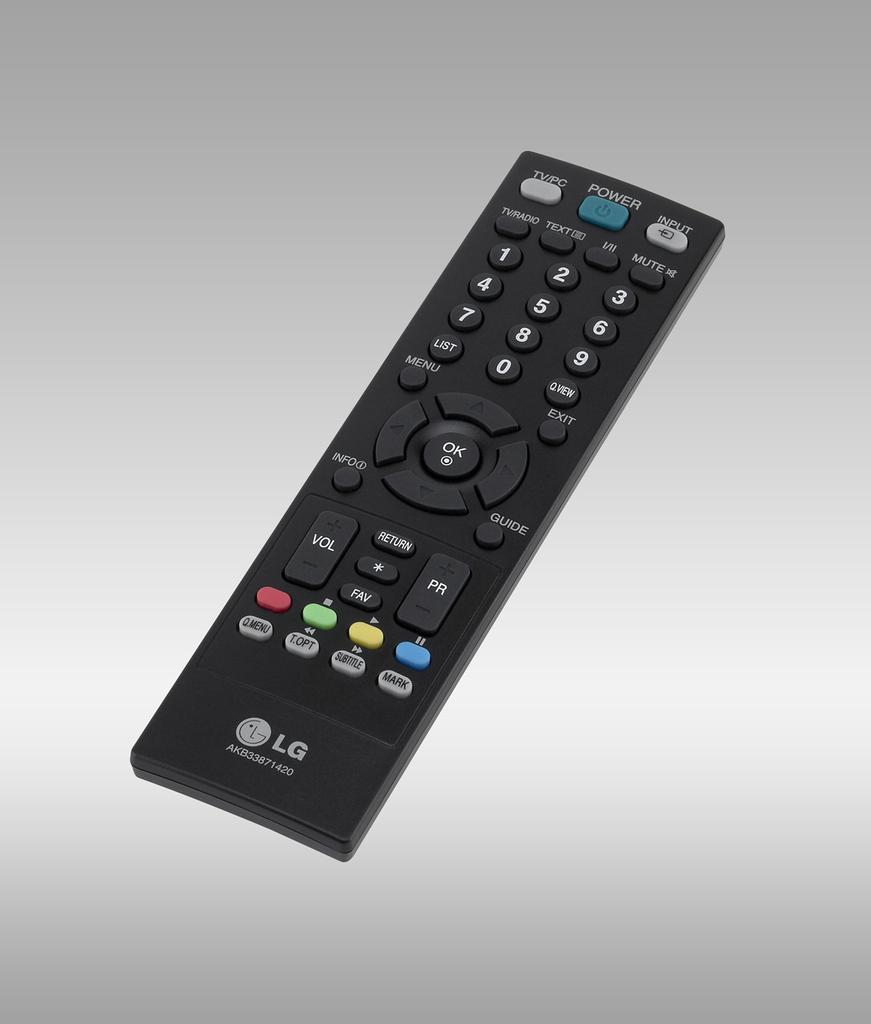What does it say on the button below the blue pause button?
Keep it short and to the point. Mark. What brand of remote is this?
Ensure brevity in your answer.  Lg. 